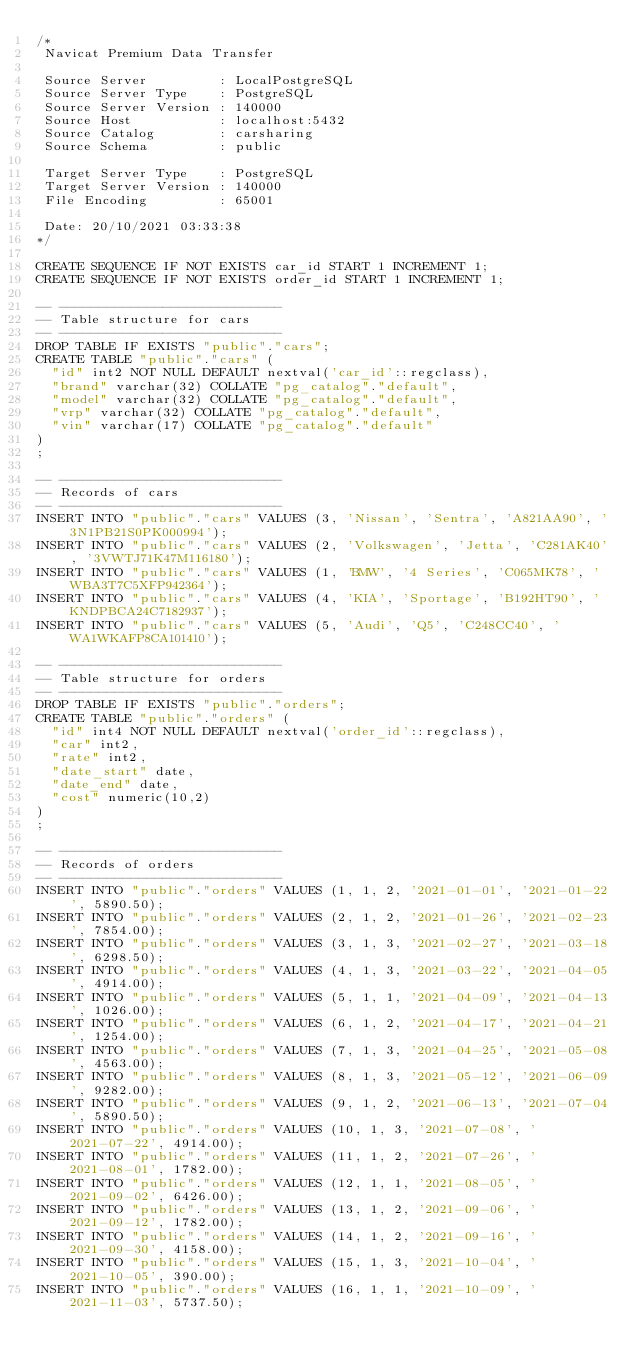<code> <loc_0><loc_0><loc_500><loc_500><_SQL_>/*
 Navicat Premium Data Transfer

 Source Server         : LocalPostgreSQL
 Source Server Type    : PostgreSQL
 Source Server Version : 140000
 Source Host           : localhost:5432
 Source Catalog        : carsharing
 Source Schema         : public

 Target Server Type    : PostgreSQL
 Target Server Version : 140000
 File Encoding         : 65001

 Date: 20/10/2021 03:33:38
*/

CREATE SEQUENCE IF NOT EXISTS car_id START 1 INCREMENT 1;
CREATE SEQUENCE IF NOT EXISTS order_id START 1 INCREMENT 1;

-- ----------------------------
-- Table structure for cars
-- ----------------------------
DROP TABLE IF EXISTS "public"."cars";
CREATE TABLE "public"."cars" (
  "id" int2 NOT NULL DEFAULT nextval('car_id'::regclass),
  "brand" varchar(32) COLLATE "pg_catalog"."default",
  "model" varchar(32) COLLATE "pg_catalog"."default",
  "vrp" varchar(32) COLLATE "pg_catalog"."default",
  "vin" varchar(17) COLLATE "pg_catalog"."default"
)
;

-- ----------------------------
-- Records of cars
-- ----------------------------
INSERT INTO "public"."cars" VALUES (3, 'Nissan', 'Sentra', 'A821AA90', '3N1PB21S0PK000994');
INSERT INTO "public"."cars" VALUES (2, 'Volkswagen', 'Jetta', 'C281AK40', '3VWTJ71K47M116180');
INSERT INTO "public"."cars" VALUES (1, 'BMW', '4 Series', 'C065MK78', 'WBA3T7C5XFP942364');
INSERT INTO "public"."cars" VALUES (4, 'KIA', 'Sportage', 'B192HT90', 'KNDPBCA24C7182937');
INSERT INTO "public"."cars" VALUES (5, 'Audi', 'Q5', 'C248CC40', 'WA1WKAFP8CA101410');

-- ----------------------------
-- Table structure for orders
-- ----------------------------
DROP TABLE IF EXISTS "public"."orders";
CREATE TABLE "public"."orders" (
  "id" int4 NOT NULL DEFAULT nextval('order_id'::regclass),
  "car" int2,
  "rate" int2,
  "date_start" date,
  "date_end" date,
  "cost" numeric(10,2)
)
;

-- ----------------------------
-- Records of orders
-- ----------------------------
INSERT INTO "public"."orders" VALUES (1, 1, 2, '2021-01-01', '2021-01-22', 5890.50);
INSERT INTO "public"."orders" VALUES (2, 1, 2, '2021-01-26', '2021-02-23', 7854.00);
INSERT INTO "public"."orders" VALUES (3, 1, 3, '2021-02-27', '2021-03-18', 6298.50);
INSERT INTO "public"."orders" VALUES (4, 1, 3, '2021-03-22', '2021-04-05', 4914.00);
INSERT INTO "public"."orders" VALUES (5, 1, 1, '2021-04-09', '2021-04-13', 1026.00);
INSERT INTO "public"."orders" VALUES (6, 1, 2, '2021-04-17', '2021-04-21', 1254.00);
INSERT INTO "public"."orders" VALUES (7, 1, 3, '2021-04-25', '2021-05-08', 4563.00);
INSERT INTO "public"."orders" VALUES (8, 1, 3, '2021-05-12', '2021-06-09', 9282.00);
INSERT INTO "public"."orders" VALUES (9, 1, 2, '2021-06-13', '2021-07-04', 5890.50);
INSERT INTO "public"."orders" VALUES (10, 1, 3, '2021-07-08', '2021-07-22', 4914.00);
INSERT INTO "public"."orders" VALUES (11, 1, 2, '2021-07-26', '2021-08-01', 1782.00);
INSERT INTO "public"."orders" VALUES (12, 1, 1, '2021-08-05', '2021-09-02', 6426.00);
INSERT INTO "public"."orders" VALUES (13, 1, 2, '2021-09-06', '2021-09-12', 1782.00);
INSERT INTO "public"."orders" VALUES (14, 1, 2, '2021-09-16', '2021-09-30', 4158.00);
INSERT INTO "public"."orders" VALUES (15, 1, 3, '2021-10-04', '2021-10-05', 390.00);
INSERT INTO "public"."orders" VALUES (16, 1, 1, '2021-10-09', '2021-11-03', 5737.50);</code> 